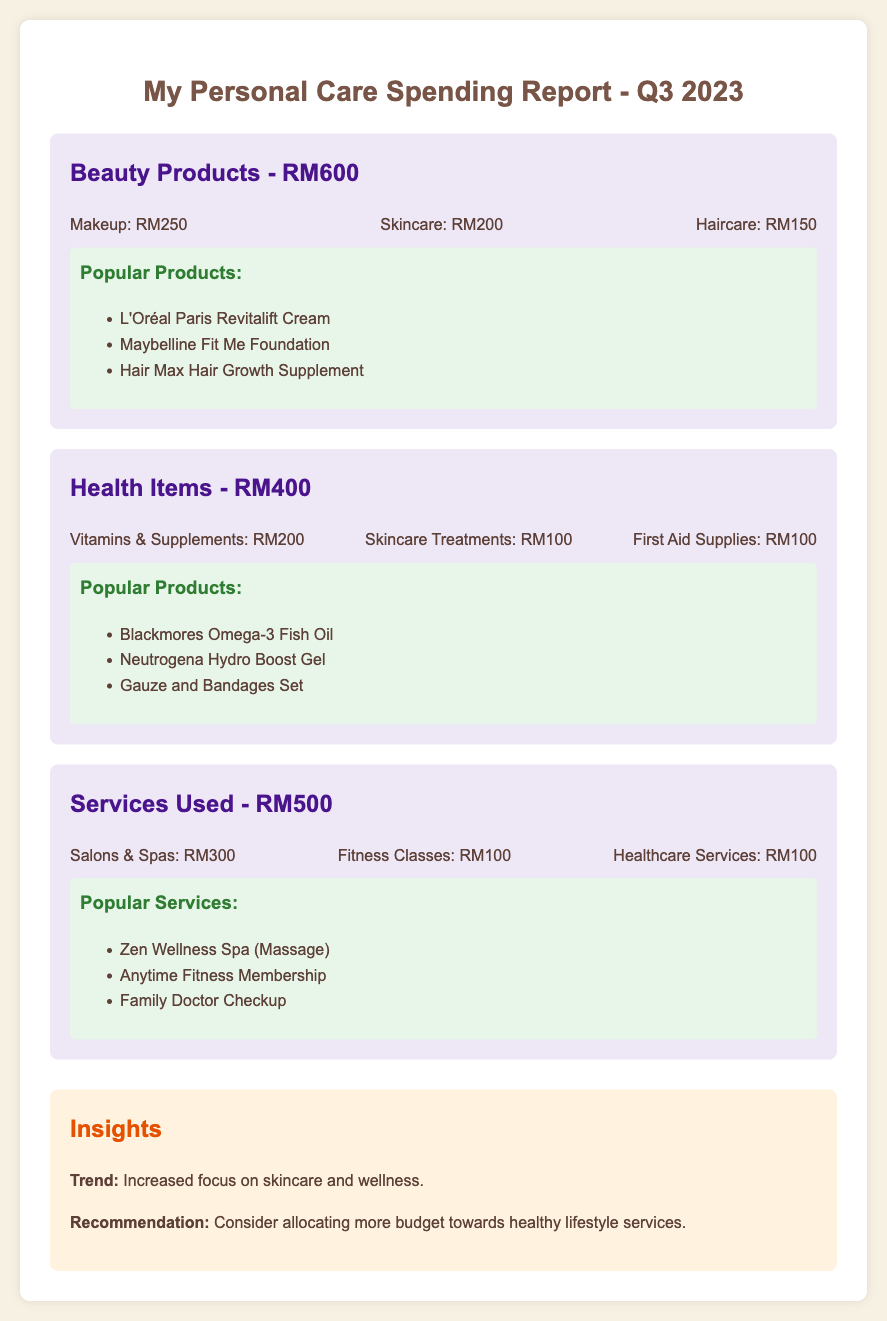What is the total expenditure on beauty products? The total expenditure on beauty products is indicated in the document as RM600.
Answer: RM600 How much was spent on vitamins and supplements? The amount spent on vitamins and supplements is detailed as RM200 under health items.
Answer: RM200 What are the total health item expenses? The total health item expenses are summed up to RM400 as shown in the document.
Answer: RM400 What is the most popular beauty product listed? The most popular beauty product mentioned is L'Oréal Paris Revitalift Cream.
Answer: L'Oréal Paris Revitalift Cream How much was spent on salon and spa services? The document indicates that RM300 was spent specifically on salons and spas services.
Answer: RM300 Which category had the highest expenditure? Services used had the highest expenditure at RM500 as shown in the document.
Answer: Services Used What is the recommendation provided in the insights? The recommendation suggests allocating more budget towards healthy lifestyle services.
Answer: Allocate more budget towards healthy lifestyle services How much was spent on first aid supplies? The expenditure on first aid supplies is detailed as RM100.
Answer: RM100 What is the trend identified in the insights? The trend identified notes an increased focus on skincare and wellness.
Answer: Increased focus on skincare and wellness 